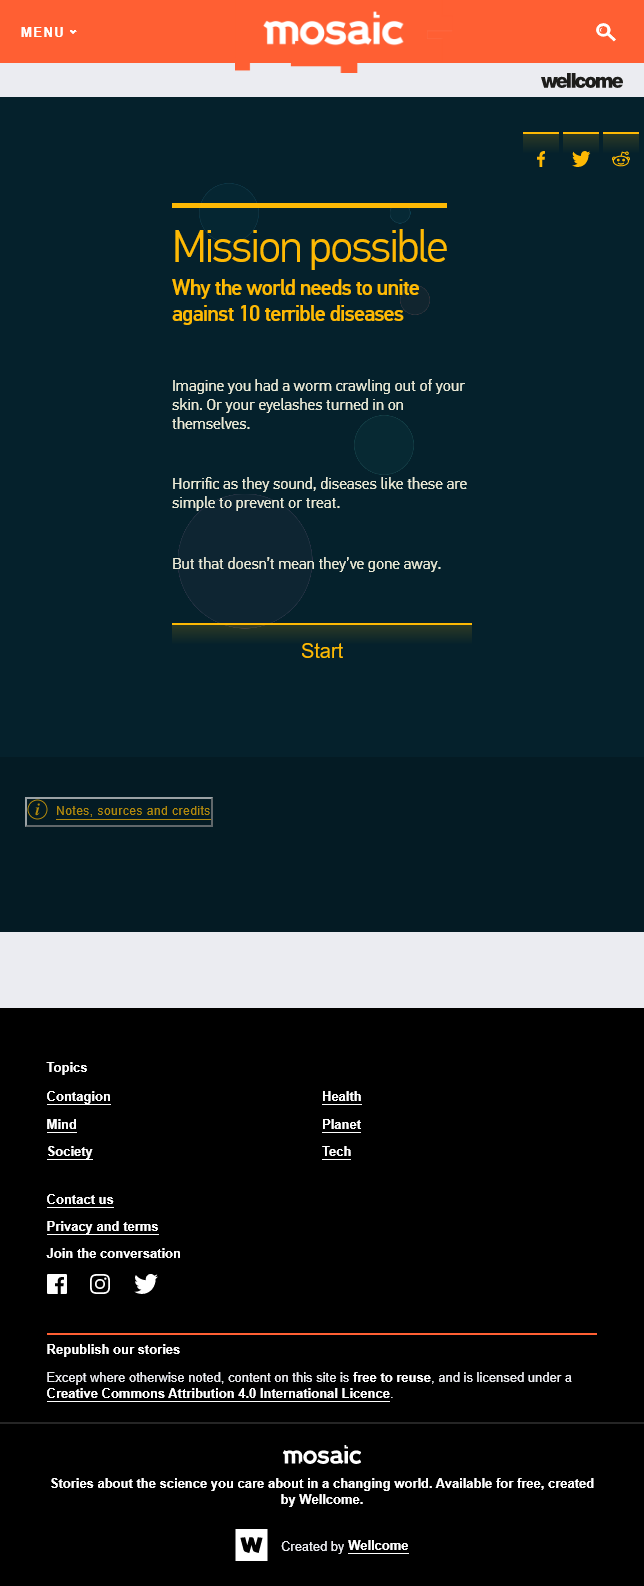Specify some key components in this picture. The article alludes to a worm emerging from one's skin. The article discusses 10 terrible diseases. The article mentions 10 terrible diseases in total. 